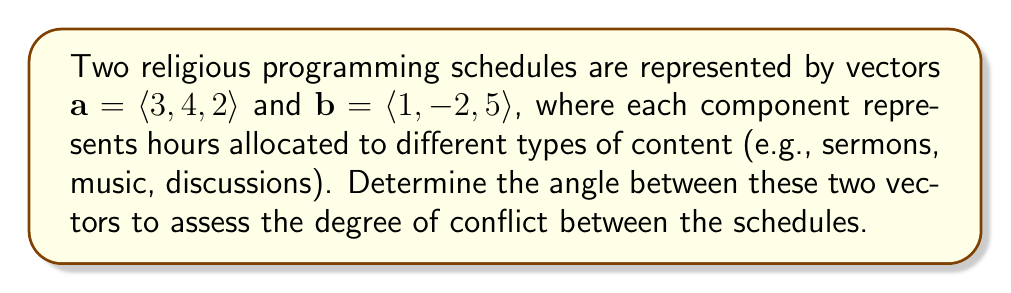Could you help me with this problem? To find the angle between two vectors, we can use the dot product formula:

$$\cos \theta = \frac{\mathbf{a} \cdot \mathbf{b}}{|\mathbf{a}||\mathbf{b}|}$$

Where $\theta$ is the angle between the vectors, $\mathbf{a} \cdot \mathbf{b}$ is the dot product, and $|\mathbf{a}|$ and $|\mathbf{b}|$ are the magnitudes of the vectors.

Step 1: Calculate the dot product $\mathbf{a} \cdot \mathbf{b}$
$$\mathbf{a} \cdot \mathbf{b} = (3)(1) + (4)(-2) + (2)(5) = 3 - 8 + 10 = 5$$

Step 2: Calculate the magnitudes of the vectors
$$|\mathbf{a}| = \sqrt{3^2 + 4^2 + 2^2} = \sqrt{9 + 16 + 4} = \sqrt{29}$$
$$|\mathbf{b}| = \sqrt{1^2 + (-2)^2 + 5^2} = \sqrt{1 + 4 + 25} = \sqrt{30}$$

Step 3: Substitute into the formula
$$\cos \theta = \frac{5}{\sqrt{29}\sqrt{30}}$$

Step 4: Solve for $\theta$ using inverse cosine
$$\theta = \arccos\left(\frac{5}{\sqrt{29}\sqrt{30}}\right)$$

Step 5: Calculate the result (rounded to two decimal places)
$$\theta \approx 1.37 \text{ radians}$$

Convert to degrees:
$$\theta \approx 1.37 \cdot \frac{180°}{\pi} \approx 78.46°$$
Answer: The angle between the two vectors representing the conflicting religious programming schedules is approximately 78.46°. 